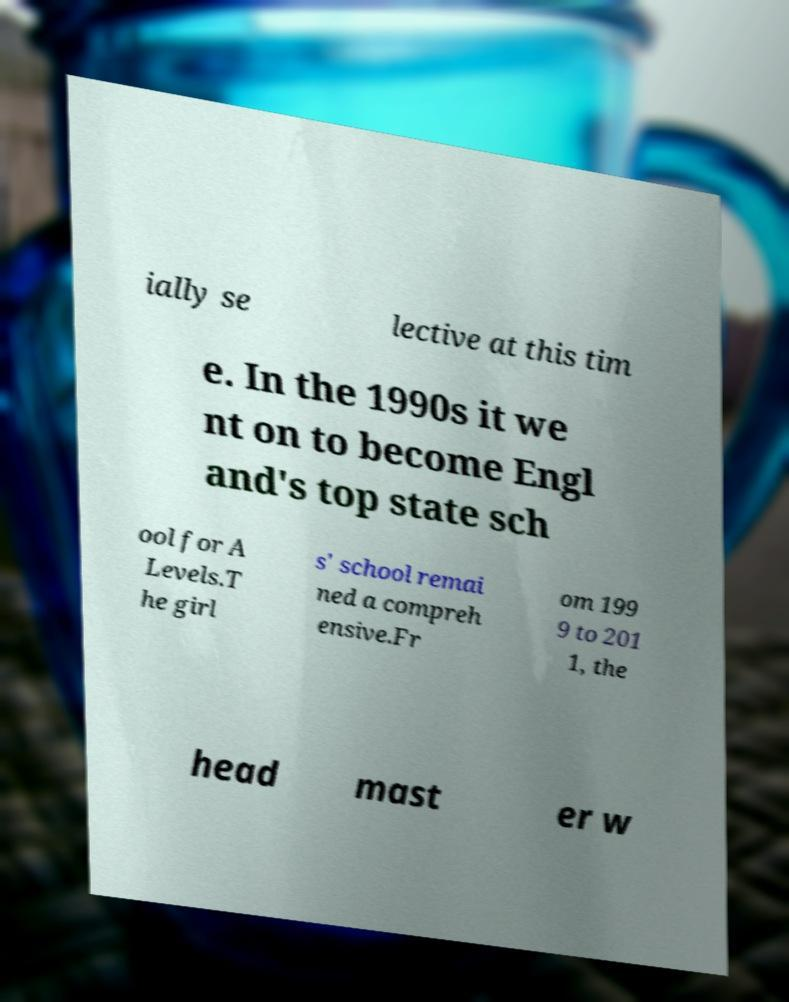Could you extract and type out the text from this image? ially se lective at this tim e. In the 1990s it we nt on to become Engl and's top state sch ool for A Levels.T he girl s' school remai ned a compreh ensive.Fr om 199 9 to 201 1, the head mast er w 